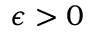<formula> <loc_0><loc_0><loc_500><loc_500>\epsilon > 0</formula> 